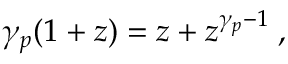Convert formula to latex. <formula><loc_0><loc_0><loc_500><loc_500>\gamma _ { p } ( 1 + z ) = z + z ^ { \gamma _ { p } - 1 } \, ,</formula> 